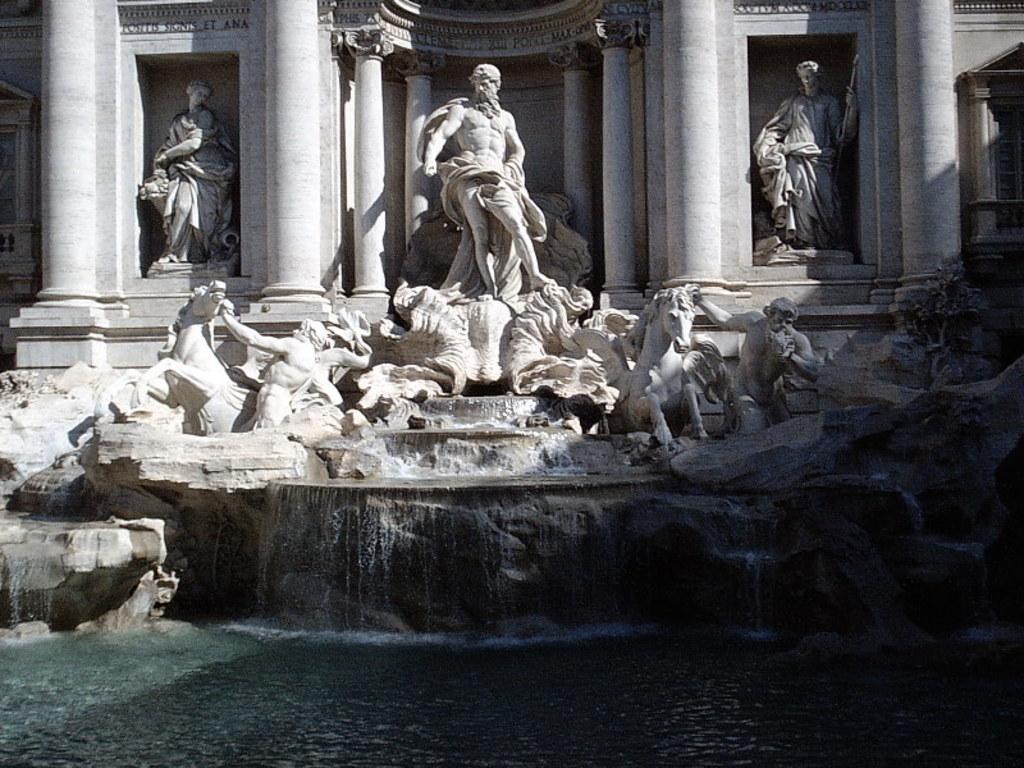How would you summarize this image in a sentence or two? This image consists of statues in the middle. There is water at the bottom. There are sculptures. 